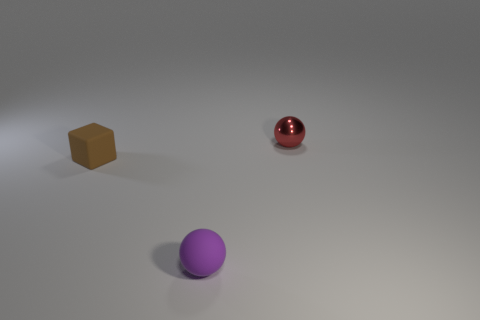How does the lighting in this scene affect the appearance of the objects? The lighting in the scene is coming from above, creating shadows underneath the objects. It enhances the three-dimensionality and textures, emphasizes the shininess of the red sphere, and reveals the matte quality of the other objects. 